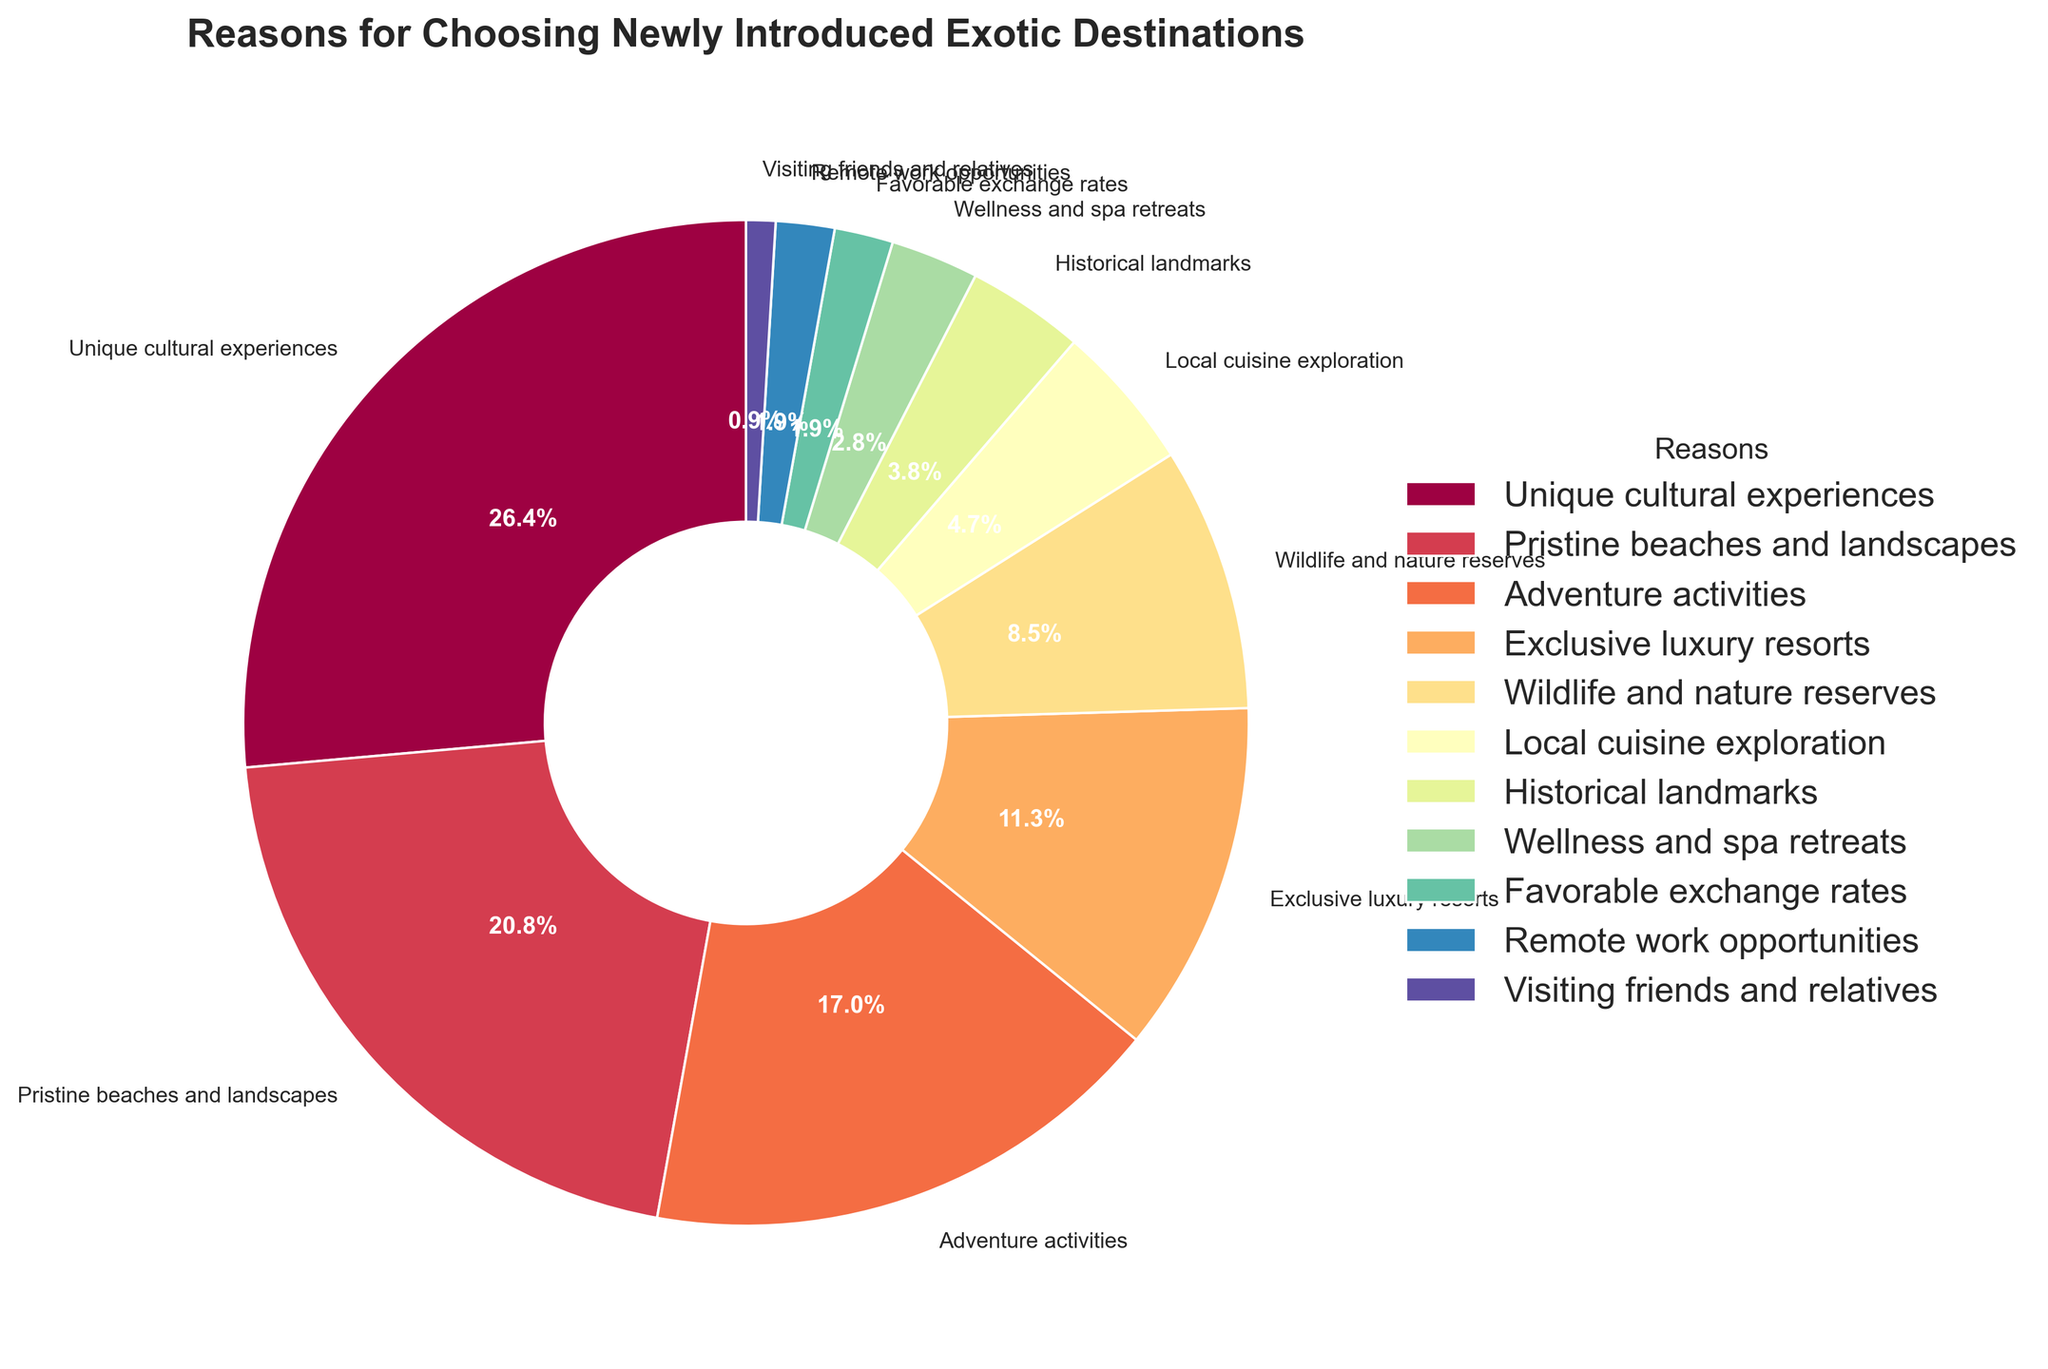Which category has the highest percentage of reasons passengers choose to visit exotic destinations? The wedge representing "Unique cultural experiences" takes up the largest portion of the pie chart at 28%.
Answer: Unique cultural experiences What is the combined percentage of passengers choosing "Pristine beaches and landscapes" and "Adventure activities"? Add the percentages for "Pristine beaches and landscapes" (22%) and "Adventure activities" (18%): 22 + 18 = 40%.
Answer: 40% Between "Wellness and spa retreats" and "Local cuisine exploration," which reason is more popular? "Local cuisine exploration" has a larger percentage (5%) compared to "Wellness and spa retreats" (3%).
Answer: Local cuisine exploration How much higher is the percentage for "Exclusive luxury resorts" compared to "Historical landmarks"? Subtract the percentage for "Historical landmarks" (4%) from "Exclusive luxury resorts" (12%): 12 - 4 = 8%.
Answer: 8% What is the percentage difference between the most popular and least popular reasons? Subtract the percentage for "Visiting friends and relatives" (1%) from "Unique cultural experiences" (28%): 28 - 1 = 27%.
Answer: 27% Which reason has the smallest percentage, and what is its value? The smallest wedge is "Visiting friends and relatives" with 1%.
Answer: Visiting friends and relatives How much does "Wildlife and nature reserves" contribute to the total percentage compared to "Exclusive luxury resorts"? "Wildlife and nature reserves" contributes 9%, while "Exclusive luxury resorts" contributes 12%. The difference is 12 - 9 = 3%.
Answer: 3% What is the total percentage for reasons related to nature and adventure (sum of "Pristine beaches and landscapes," "Adventure activities," and "Wildlife and nature reserves")? Sum up the percentages for "Pristine beaches and landscapes" (22%), "Adventure activities" (18%), and "Wildlife and nature reserves" (9%): 22 + 18 + 9 = 49%.
Answer: 49% Which two adjacent categories in the legend have the closest percentages? "Wellness and spa retreats" (3%) and "Favorable exchange rates" (2%) have a percentage difference of 1%, which is the smallest difference.
Answer: Wellness and spa retreats and Favorable exchange rates Is the percentage for "Remote work opportunities" higher than that for "Visiting friends and relatives"? Yes, "Remote work opportunities" has 2%, which is higher than "Visiting friends and relatives" at 1%.
Answer: Yes 